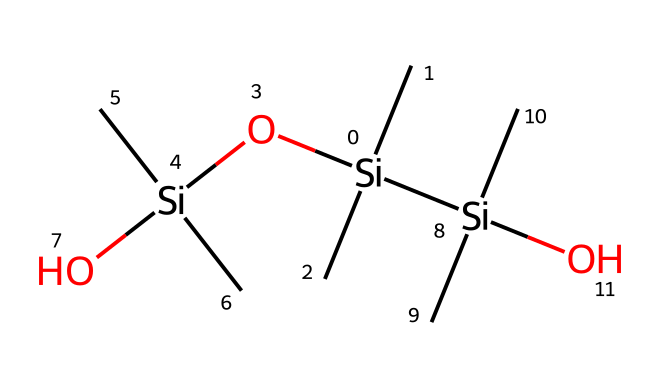What elements are present in this polymer structure? The SMILES representation contains silicon (Si) and oxygen (O) atoms, which are indicated by their chemical symbols. Each silicon atom is bonded to four methyl groups (C), also visible in the structure's notation.
Answer: silicon, oxygen, carbon How many silicon atoms are there in this structure? By counting the occurrences of the silicon atom symbol (Si) in the SMILES representation, we find three silicon atoms present in the polymer structure.
Answer: three What is the functionality of the oxygen atoms in this chemical? The oxygen atoms act as linkages between the silicon atoms, helping to form the siloxane bonds (Si-O) that create the flexible network characteristic of silicone rubber.
Answer: linkages What type of polymer is formed by this structure? This structure illustrates a silicone rubber polymer, characterized by its alternating silicon and oxygen atoms that provide flexibility and resilience.
Answer: silicone rubber What characteristic property is implied by the combination of silicon and oxygen? The combination of silicon and oxygen typically implies flexibility and thermal stability, properties essential for making durable and flexible prop masks.
Answer: flexibility How many methyl groups are bonded to each silicon atom? Each silicon atom in the structure is bonded to three methyl groups as indicated by the three methyl groups connected to each Si in the SMILES representation.
Answer: three 